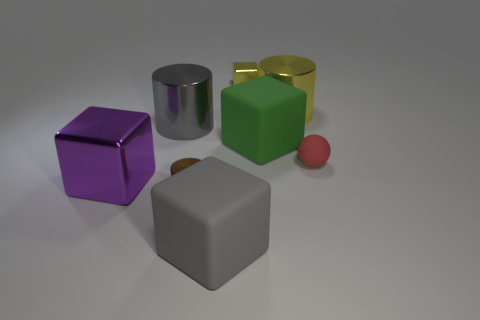Are the green object and the object on the left side of the big gray cylinder made of the same material?
Your answer should be very brief. No. How many brown things are either small shiny things or large matte things?
Offer a very short reply. 1. The purple block that is made of the same material as the big yellow cylinder is what size?
Give a very brief answer. Large. What number of large gray metal things are the same shape as the big yellow metal object?
Give a very brief answer. 1. Are there more tiny yellow objects that are in front of the big purple shiny block than large gray cylinders that are in front of the green object?
Provide a short and direct response. No. There is a small cube; is it the same color as the shiny cylinder that is on the right side of the small brown object?
Give a very brief answer. Yes. There is a purple cube that is the same size as the gray metallic cylinder; what is it made of?
Provide a succinct answer. Metal. How many things are either big red matte objects or big gray objects that are behind the tiny red sphere?
Your answer should be very brief. 1. Is the size of the yellow cylinder the same as the brown shiny object in front of the small red object?
Make the answer very short. No. How many balls are yellow objects or red rubber objects?
Offer a terse response. 1. 